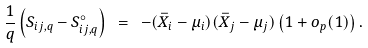Convert formula to latex. <formula><loc_0><loc_0><loc_500><loc_500>\frac { 1 } { q } \left ( S _ { i j , q } - S ^ { \circ } _ { i j , q } \right ) \ = \ - ( \bar { X } _ { i } - \mu _ { i } ) ( \bar { X } _ { j } - \mu _ { j } ) \left ( 1 + o _ { p } ( 1 ) \right ) .</formula> 